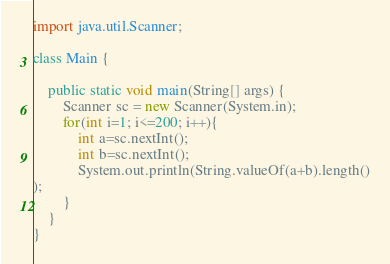Convert code to text. <code><loc_0><loc_0><loc_500><loc_500><_Java_>import java.util.Scanner;

class Main {

	public static void main(String[] args) {
		Scanner sc = new Scanner(System.in);
		for(int i=1; i<=200; i++){
			int a=sc.nextInt();
			int b=sc.nextInt();
			System.out.println(String.valueOf(a+b).length()
);
		}
	}
}</code> 